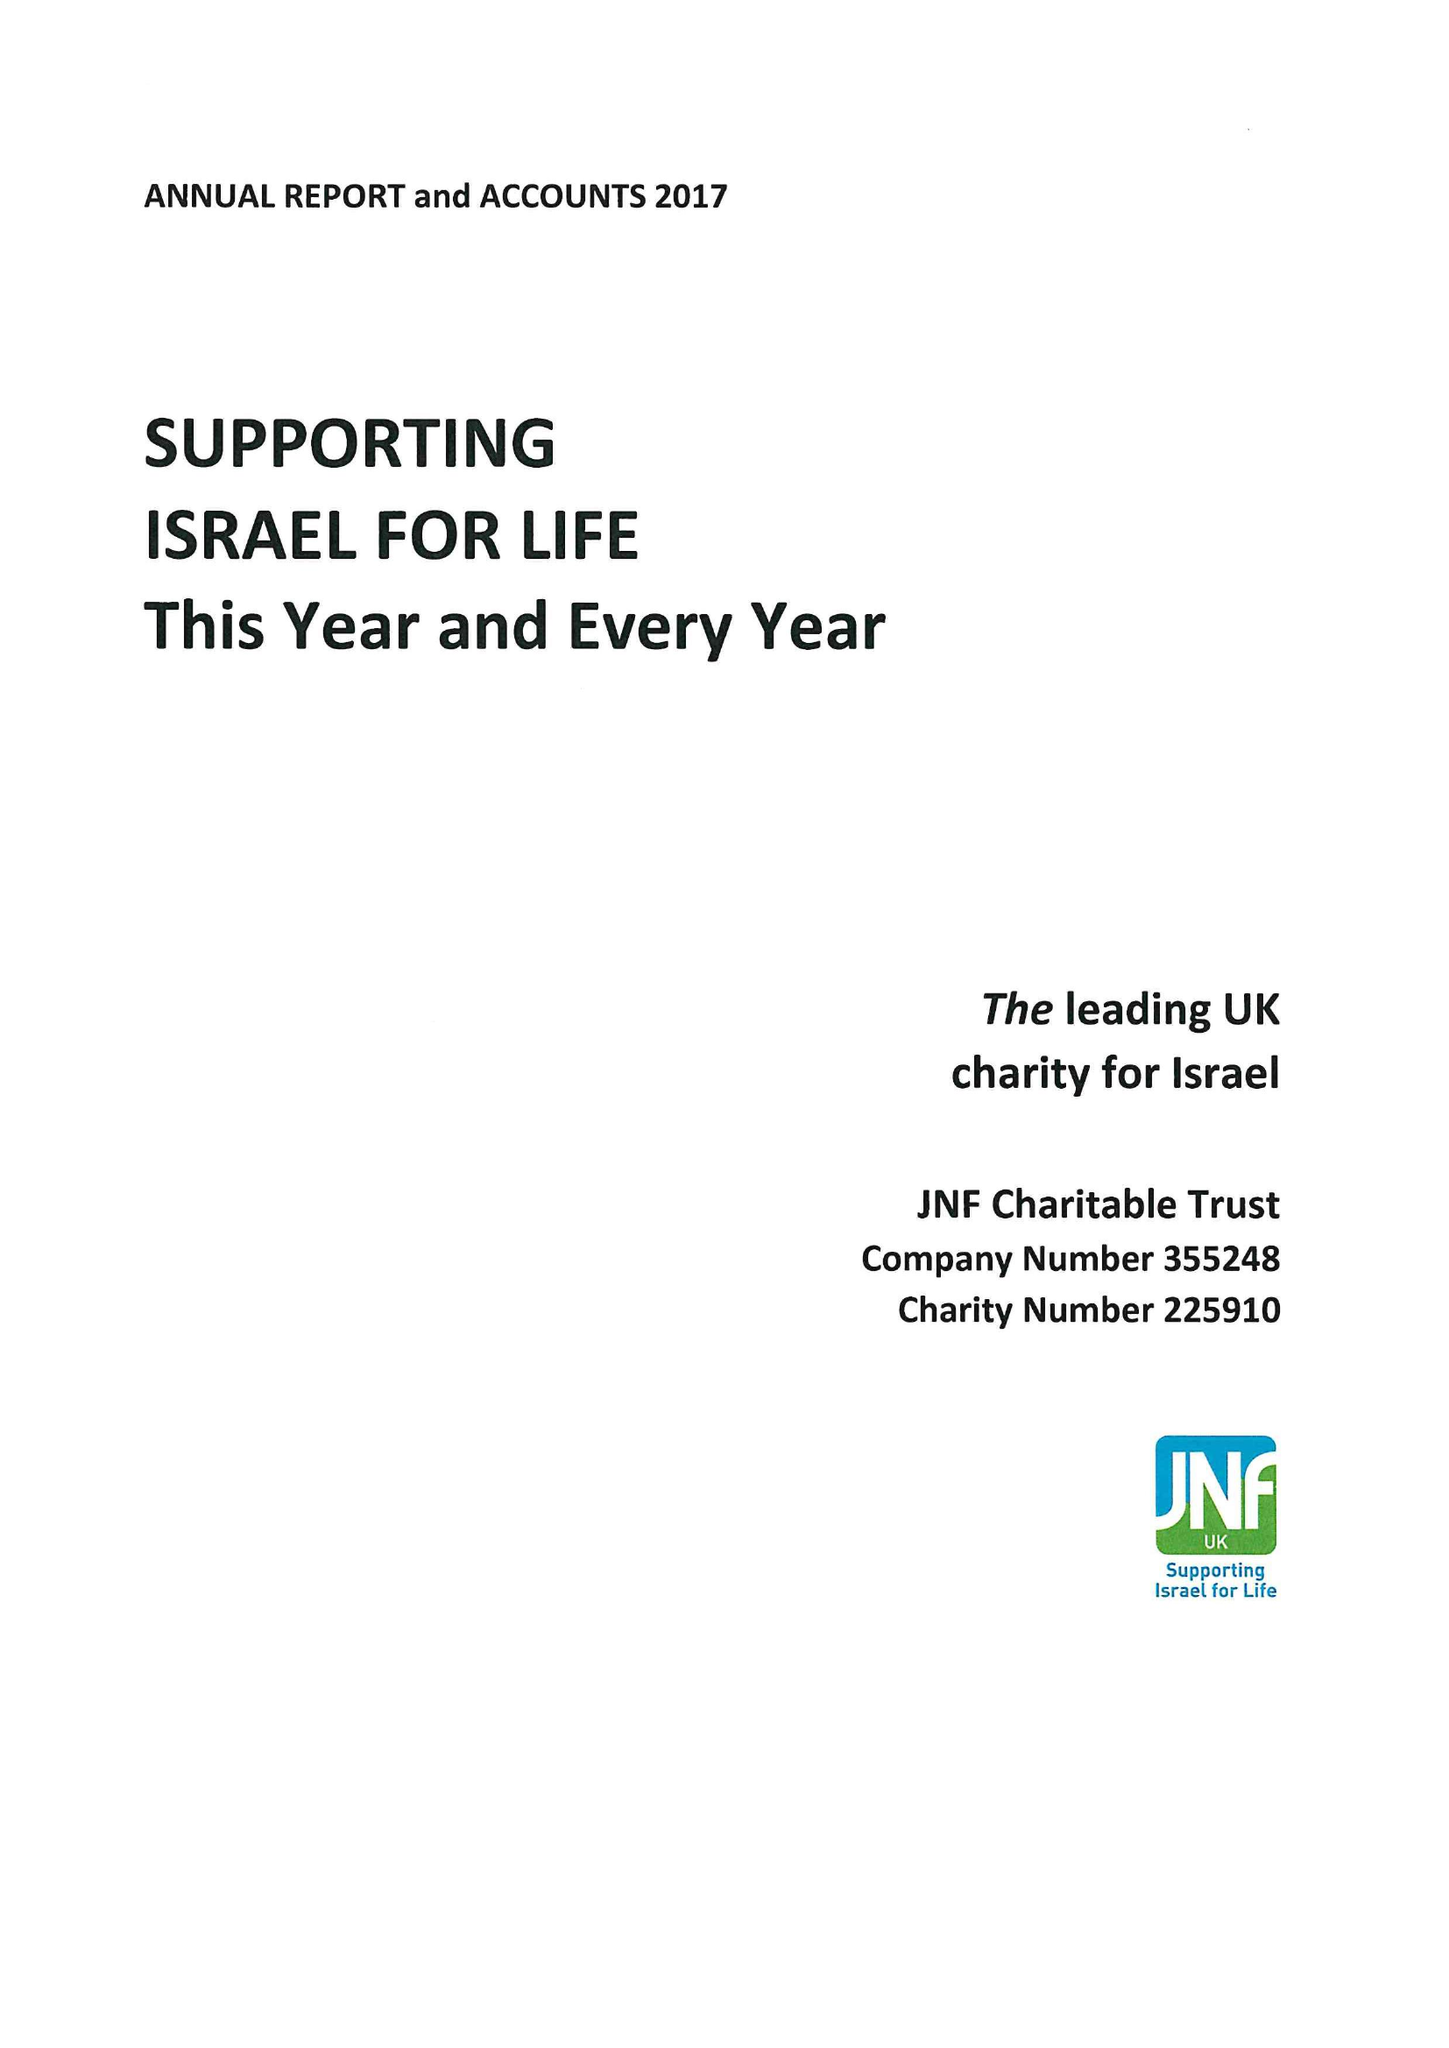What is the value for the charity_number?
Answer the question using a single word or phrase. 225910 